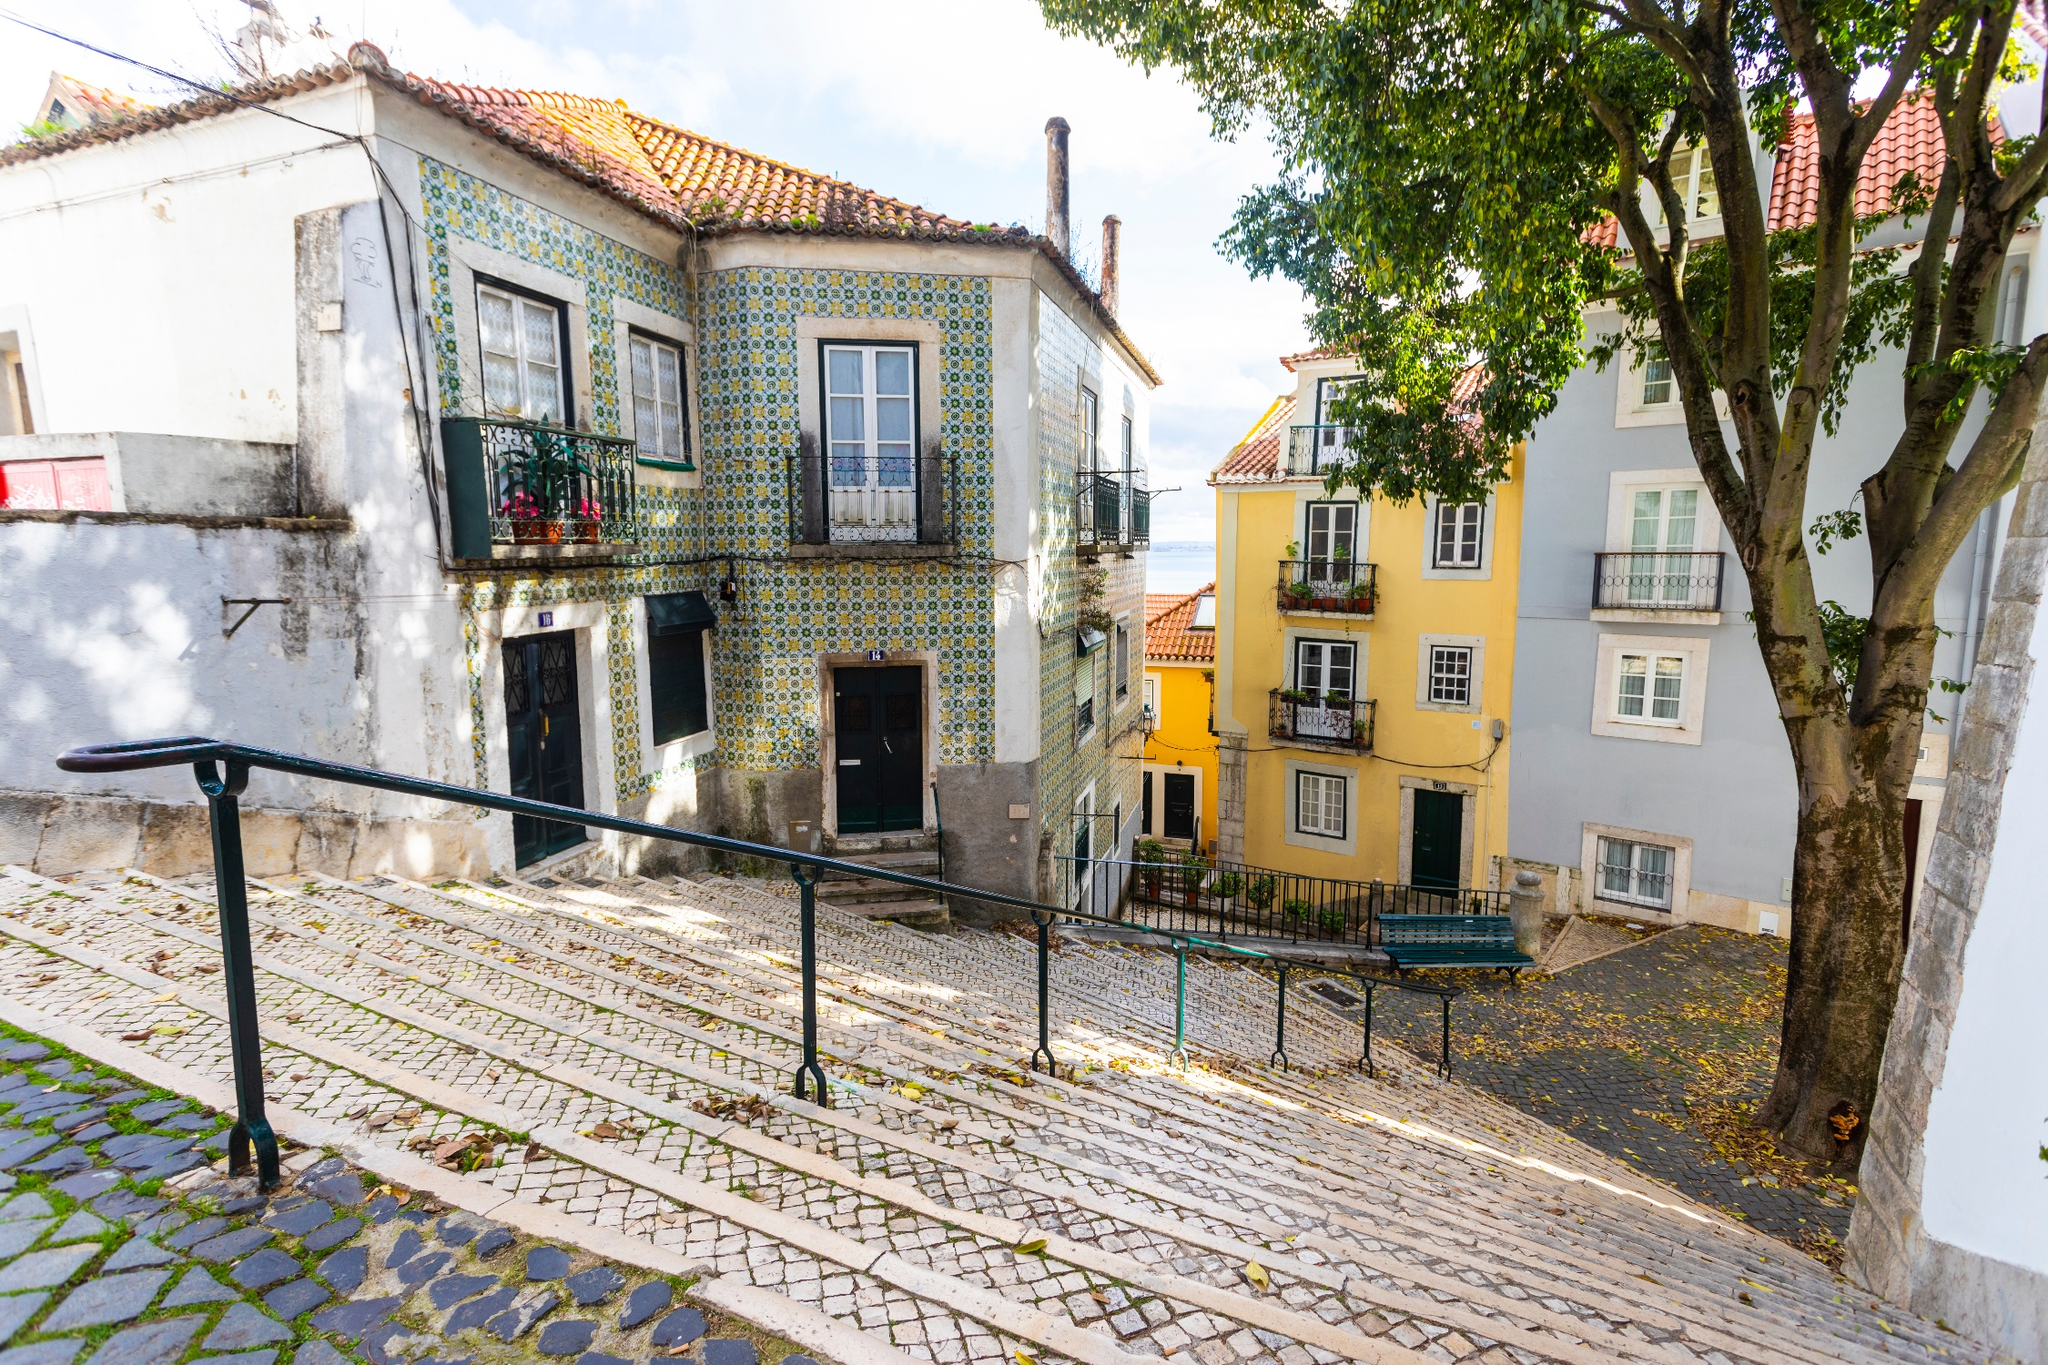Could this street be part of a famous movie scene? If so, describe the context. This street could definitely be part of a famous movie scene. Imagine a romantic film set in the heart of Lisbon, where the protagonists meet for the first time on this charming street. The heroine, exploring the city, accidentally drops a book of local architecture that she has been annotating. The hero, an architect by profession, happens to be walking by and helps her pick it up. Their hands brush against each other, and amidst the beautiful tiled facades and quaint charm of the street, a spark of romance ignites. The cobblestones, the vibrant colors of the buildings, and the serene ambiance become the backdrop for their budding relationship. 